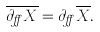<formula> <loc_0><loc_0><loc_500><loc_500>\overline { \partial _ { \alpha } X } = \partial _ { \alpha } \overline { X } .</formula> 